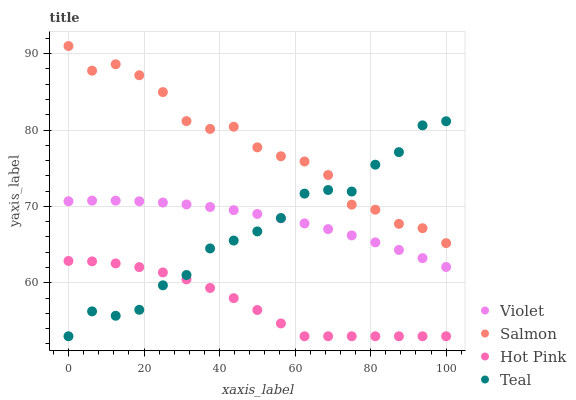Does Hot Pink have the minimum area under the curve?
Answer yes or no. Yes. Does Salmon have the maximum area under the curve?
Answer yes or no. Yes. Does Teal have the minimum area under the curve?
Answer yes or no. No. Does Teal have the maximum area under the curve?
Answer yes or no. No. Is Violet the smoothest?
Answer yes or no. Yes. Is Teal the roughest?
Answer yes or no. Yes. Is Salmon the smoothest?
Answer yes or no. No. Is Salmon the roughest?
Answer yes or no. No. Does Hot Pink have the lowest value?
Answer yes or no. Yes. Does Salmon have the lowest value?
Answer yes or no. No. Does Salmon have the highest value?
Answer yes or no. Yes. Does Teal have the highest value?
Answer yes or no. No. Is Violet less than Salmon?
Answer yes or no. Yes. Is Salmon greater than Violet?
Answer yes or no. Yes. Does Hot Pink intersect Teal?
Answer yes or no. Yes. Is Hot Pink less than Teal?
Answer yes or no. No. Is Hot Pink greater than Teal?
Answer yes or no. No. Does Violet intersect Salmon?
Answer yes or no. No. 